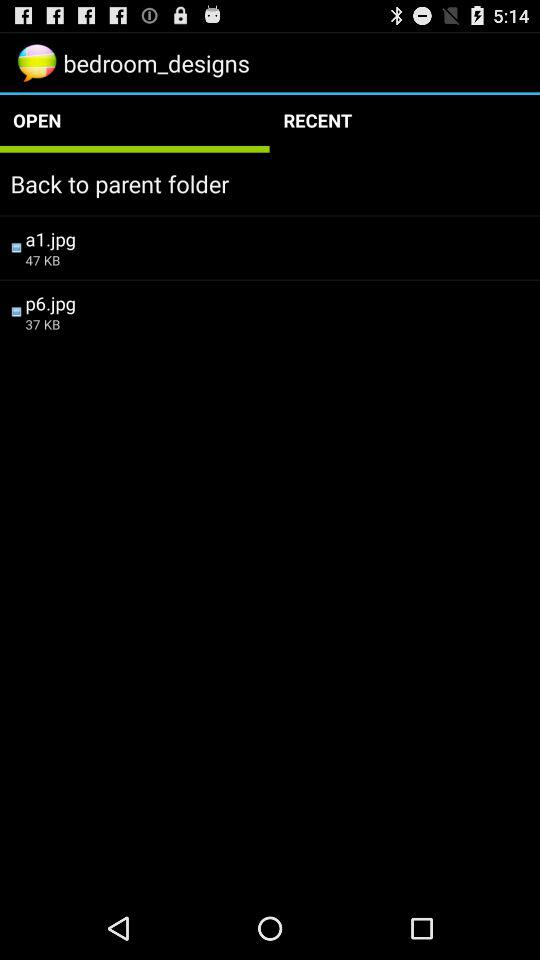What is the size of a1.jpg? The size of a1.jpg is 47 KB. 